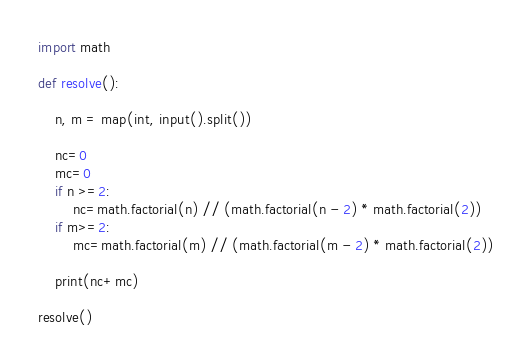<code> <loc_0><loc_0><loc_500><loc_500><_Python_>import math

def resolve():

    n, m = map(int, input().split())

    nc=0
    mc=0
    if n >=2:
        nc=math.factorial(n) // (math.factorial(n - 2) * math.factorial(2))
    if m>=2:
        mc=math.factorial(m) // (math.factorial(m - 2) * math.factorial(2))

    print(nc+mc)

resolve()</code> 